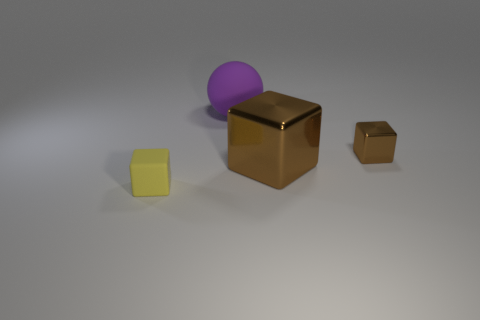The block that is the same color as the big metal thing is what size?
Provide a succinct answer. Small. What shape is the other metallic thing that is the same color as the large metal thing?
Keep it short and to the point. Cube. There is a block on the left side of the purple thing; is its size the same as the small brown metal object?
Provide a succinct answer. Yes. There is a large thing that is in front of the large rubber sphere; what material is it?
Make the answer very short. Metal. Is the number of large matte balls to the left of the small yellow object the same as the number of small metal blocks right of the large matte ball?
Ensure brevity in your answer.  No. There is a tiny metallic object that is the same shape as the small yellow matte object; what color is it?
Provide a short and direct response. Brown. Are there any other things that have the same color as the big shiny block?
Keep it short and to the point. Yes. How many matte objects are either small yellow blocks or cubes?
Make the answer very short. 1. Does the large rubber object have the same color as the big metal block?
Offer a terse response. No. Is the number of large purple objects in front of the purple matte thing greater than the number of brown metallic blocks?
Your answer should be compact. No. 